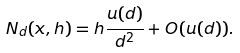<formula> <loc_0><loc_0><loc_500><loc_500>N _ { d } ( x , h ) = h \frac { u ( d ) } { d ^ { 2 } } + O ( u ( d ) ) .</formula> 